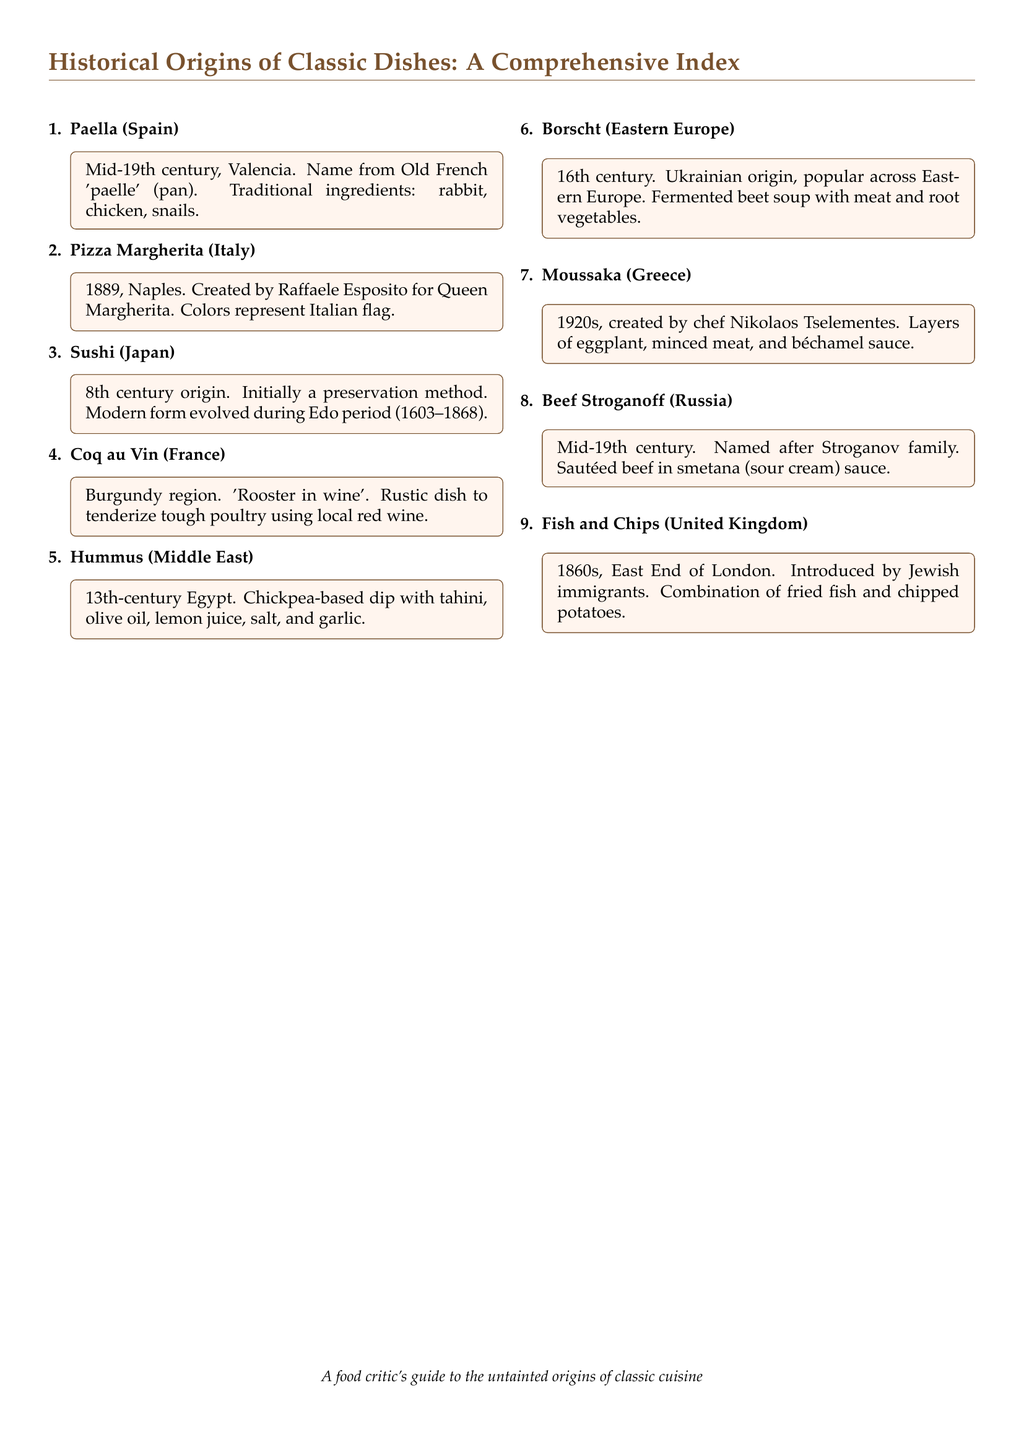What is the origin of Paella? The origin of Paella is Valencia, Spain, in the mid-19th century.
Answer: Valencia, Spain In what year was Pizza Margherita created? Pizza Margherita was created in 1889.
Answer: 1889 What dish is referred to as 'Rooster in wine'? 'Rooster in wine' refers to Coq au Vin.
Answer: Coq au Vin What main ingredient is used in Hummus? The main ingredient used in Hummus is chickpeas.
Answer: Chickpeas From which region does Borscht originate? Borscht originates from the Ukrainian region of Eastern Europe.
Answer: Ukrainian Who created Moussaka? Moussaka was created by chef Nikolaos Tselementes.
Answer: Nikolaos Tselementes What does the name "Pizza Margherita" represent? The name "Pizza Margherita" represents the colors of the Italian flag.
Answer: Italian flag In which century did Sushi originate? Sushi originated in the 8th century.
Answer: 8th century What type of sauce is used in Beef Stroganoff? The type of sauce used in Beef Stroganoff is smetana (sour cream) sauce.
Answer: smetana (sour cream) sauce 